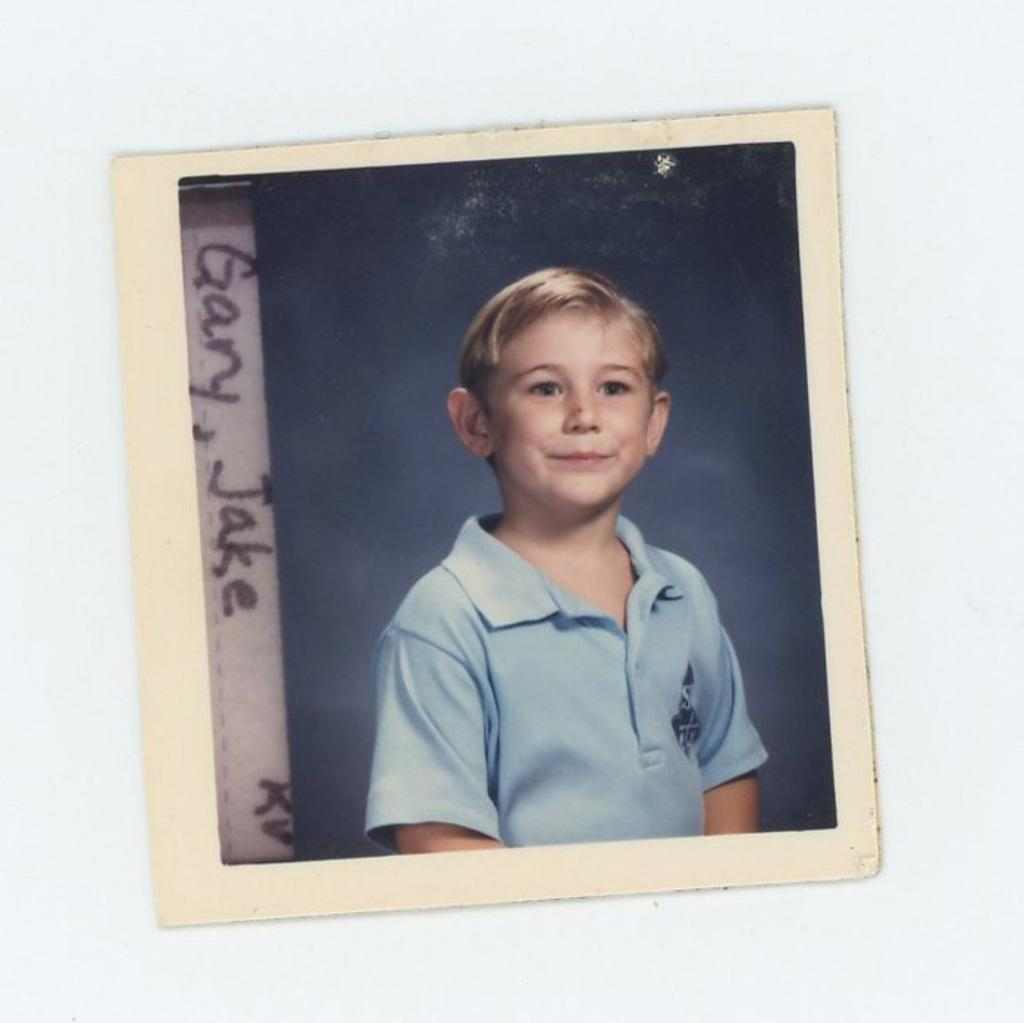What is hanging on the wall in the image? There is a photo frame on the wall. What is inside the photo frame? The photo frame contains a depiction of a person. Is there any text present in the photo frame? Yes, there is text present in the photo frame. What type of shirt is the person wearing in the photo frame? There is no shirt visible in the photo frame, as it only contains a depiction of a person. 